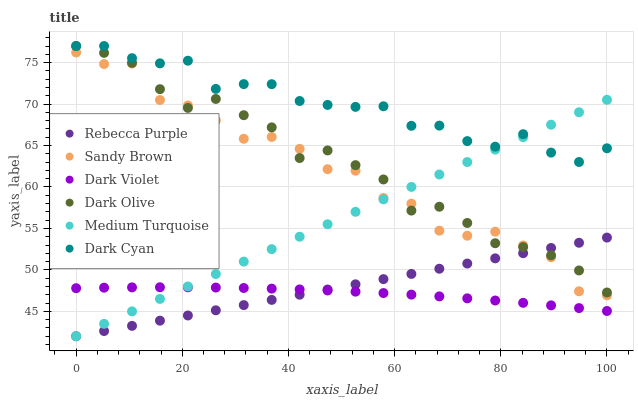Does Dark Violet have the minimum area under the curve?
Answer yes or no. Yes. Does Dark Cyan have the maximum area under the curve?
Answer yes or no. Yes. Does Rebecca Purple have the minimum area under the curve?
Answer yes or no. No. Does Rebecca Purple have the maximum area under the curve?
Answer yes or no. No. Is Rebecca Purple the smoothest?
Answer yes or no. Yes. Is Sandy Brown the roughest?
Answer yes or no. Yes. Is Dark Violet the smoothest?
Answer yes or no. No. Is Dark Violet the roughest?
Answer yes or no. No. Does Rebecca Purple have the lowest value?
Answer yes or no. Yes. Does Dark Violet have the lowest value?
Answer yes or no. No. Does Dark Cyan have the highest value?
Answer yes or no. Yes. Does Rebecca Purple have the highest value?
Answer yes or no. No. Is Dark Violet less than Dark Cyan?
Answer yes or no. Yes. Is Sandy Brown greater than Dark Violet?
Answer yes or no. Yes. Does Dark Olive intersect Rebecca Purple?
Answer yes or no. Yes. Is Dark Olive less than Rebecca Purple?
Answer yes or no. No. Is Dark Olive greater than Rebecca Purple?
Answer yes or no. No. Does Dark Violet intersect Dark Cyan?
Answer yes or no. No. 